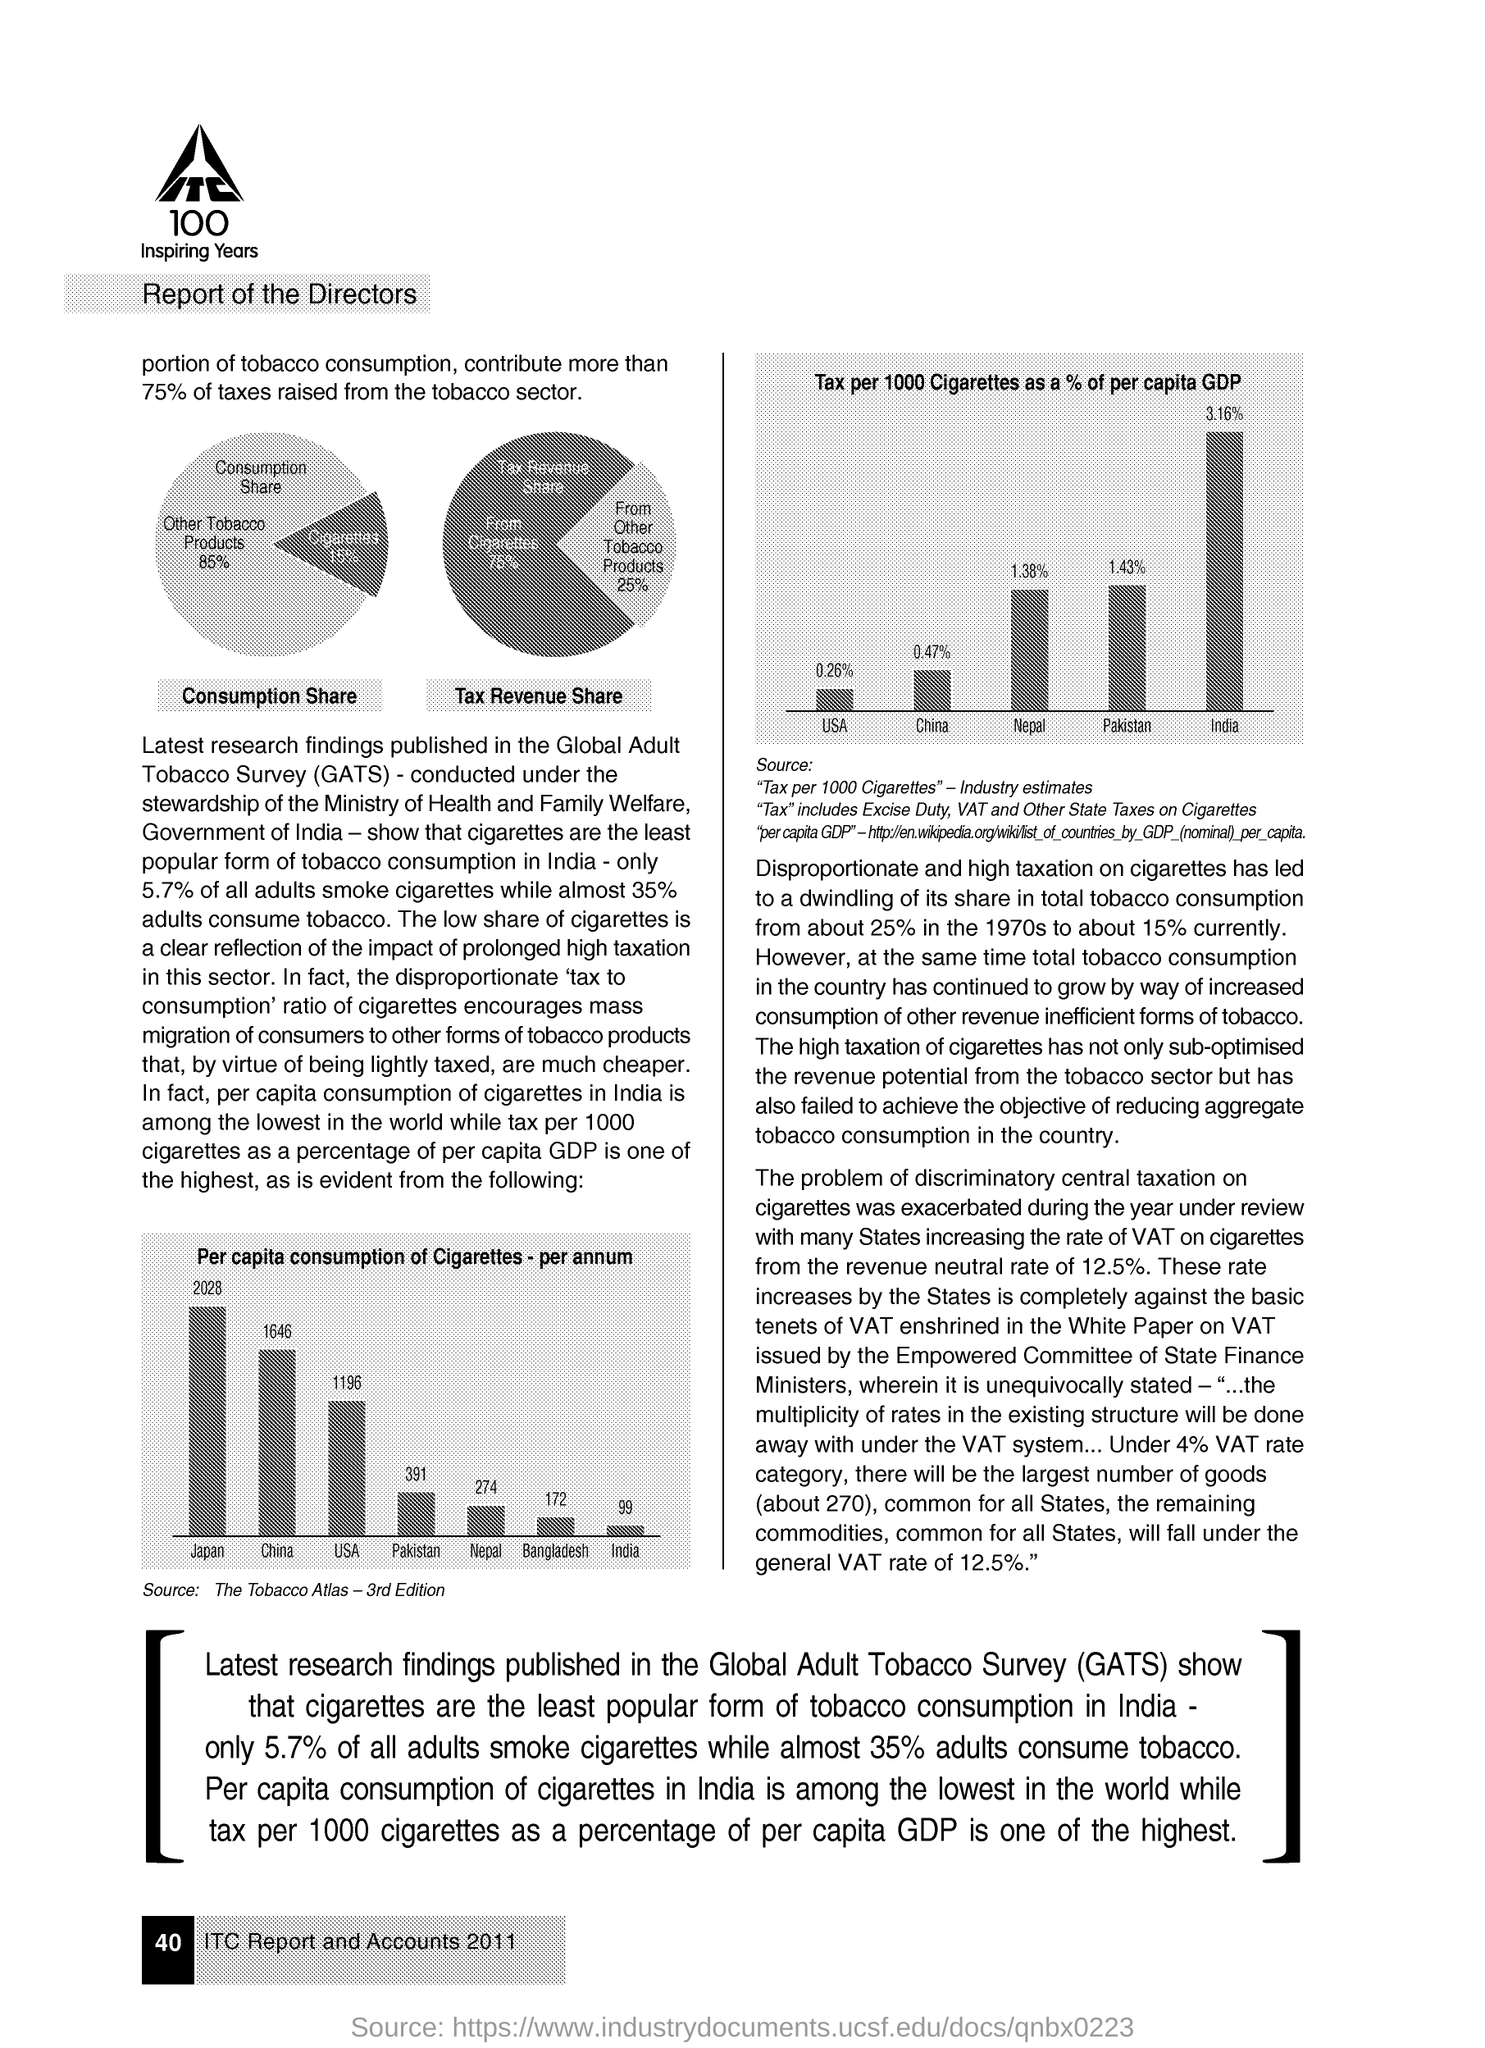Highlight a few significant elements in this photo. The full form of GATS is Global Adult Tobacco Survey. 